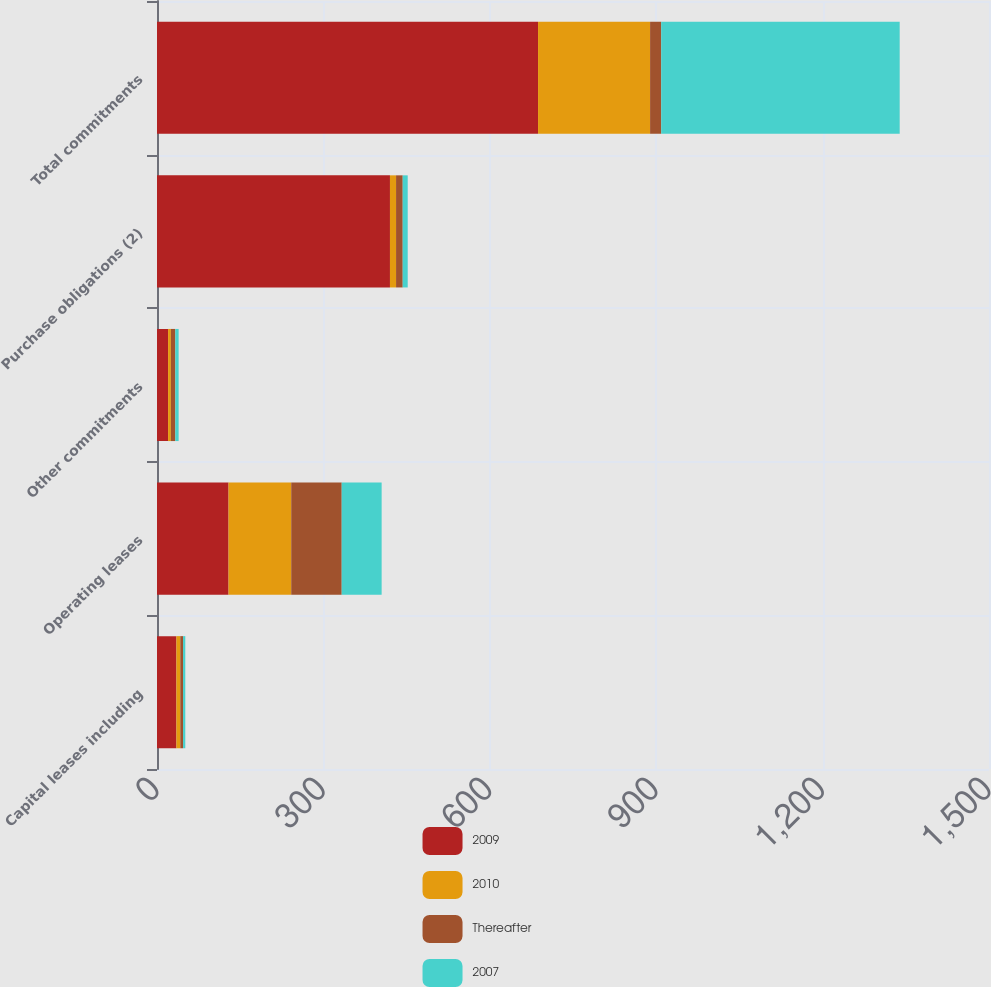<chart> <loc_0><loc_0><loc_500><loc_500><stacked_bar_chart><ecel><fcel>Capital leases including<fcel>Operating leases<fcel>Other commitments<fcel>Purchase obligations (2)<fcel>Total commitments<nl><fcel>2009<fcel>35<fcel>129<fcel>20<fcel>420<fcel>687<nl><fcel>2010<fcel>7<fcel>113<fcel>5<fcel>11<fcel>202<nl><fcel>Thereafter<fcel>5<fcel>91<fcel>8<fcel>12<fcel>20<nl><fcel>2007<fcel>4<fcel>72<fcel>6<fcel>9<fcel>430<nl></chart> 